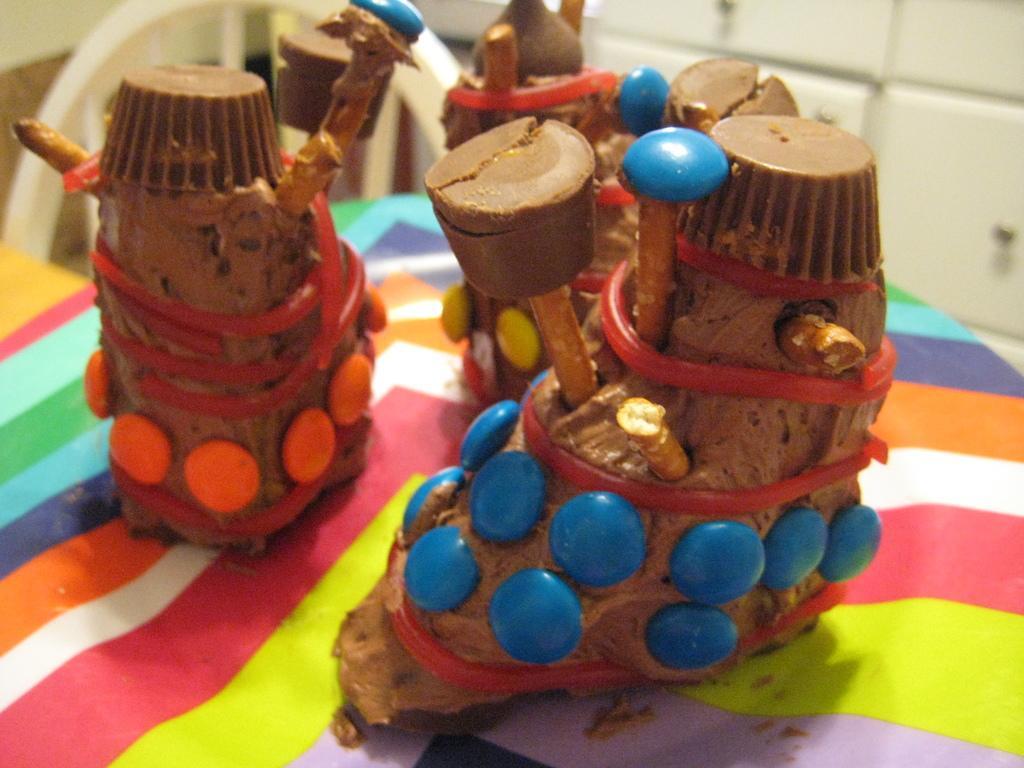In one or two sentences, can you explain what this image depicts? In the image in the center we can see one table. On the table,we can see one cloth,chocolate cakes and gems,which are in blue,yellow and orange color. In the background there is a wall and chair. 